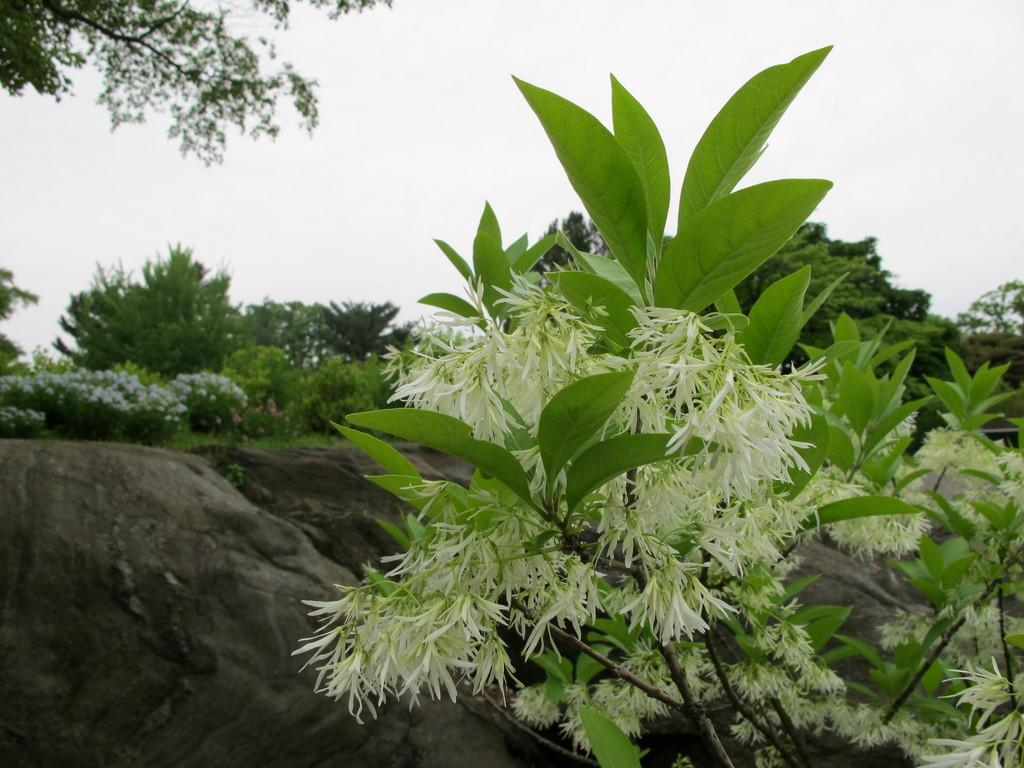What type of plants can be seen in the image? There are white flower plants in the image. What other objects or features are present in the image? There are rocks and trees in the image. Where are the trees located in relation to the other elements in the image? The trees are located at the back of the image. How many knees can be seen in the image? There are no knees visible in the image. What type of currency is present in the image? There is no currency present in the image. 